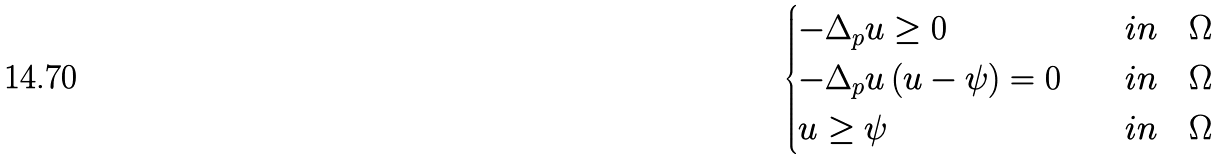<formula> <loc_0><loc_0><loc_500><loc_500>\begin{cases} - \Delta _ { p } u \geq 0 & \quad i n \quad \Omega \\ - \Delta _ { p } u \, ( u - \psi ) = 0 & \quad i n \quad \Omega \\ u \geq \psi & \quad i n \quad \Omega \end{cases}</formula> 